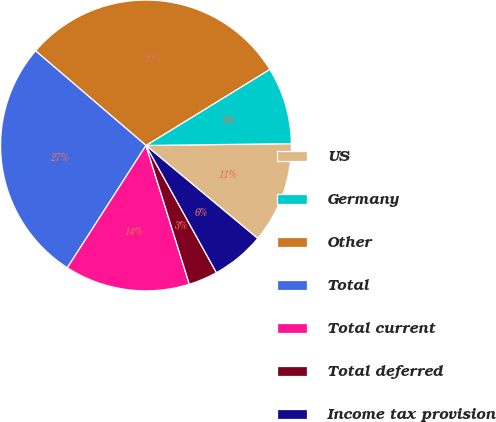Convert chart. <chart><loc_0><loc_0><loc_500><loc_500><pie_chart><fcel>US<fcel>Germany<fcel>Other<fcel>Total<fcel>Total current<fcel>Total deferred<fcel>Income tax provision<nl><fcel>11.25%<fcel>8.57%<fcel>29.95%<fcel>27.18%<fcel>13.92%<fcel>3.23%<fcel>5.9%<nl></chart> 